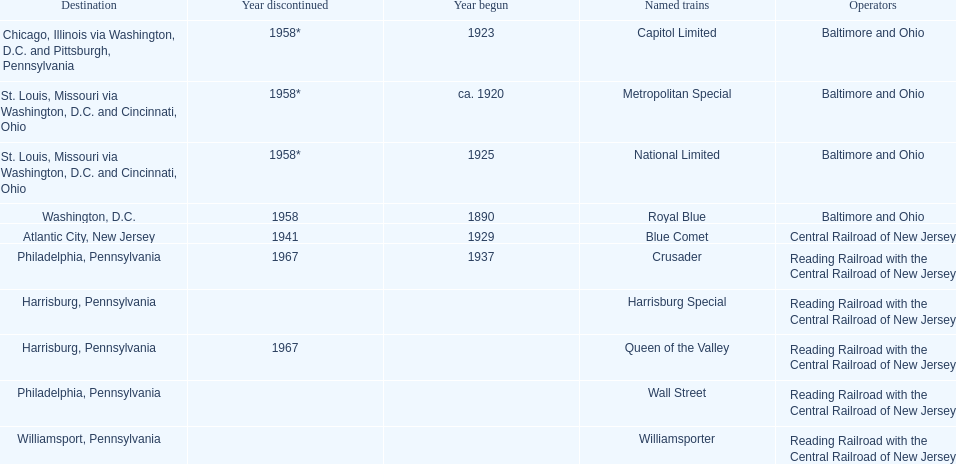Which train ran for the longest time? Royal Blue. Could you parse the entire table? {'header': ['Destination', 'Year discontinued', 'Year begun', 'Named trains', 'Operators'], 'rows': [['Chicago, Illinois via Washington, D.C. and Pittsburgh, Pennsylvania', '1958*', '1923', 'Capitol Limited', 'Baltimore and Ohio'], ['St. Louis, Missouri via Washington, D.C. and Cincinnati, Ohio', '1958*', 'ca. 1920', 'Metropolitan Special', 'Baltimore and Ohio'], ['St. Louis, Missouri via Washington, D.C. and Cincinnati, Ohio', '1958*', '1925', 'National Limited', 'Baltimore and Ohio'], ['Washington, D.C.', '1958', '1890', 'Royal Blue', 'Baltimore and Ohio'], ['Atlantic City, New Jersey', '1941', '1929', 'Blue Comet', 'Central Railroad of New Jersey'], ['Philadelphia, Pennsylvania', '1967', '1937', 'Crusader', 'Reading Railroad with the Central Railroad of New Jersey'], ['Harrisburg, Pennsylvania', '', '', 'Harrisburg Special', 'Reading Railroad with the Central Railroad of New Jersey'], ['Harrisburg, Pennsylvania', '1967', '', 'Queen of the Valley', 'Reading Railroad with the Central Railroad of New Jersey'], ['Philadelphia, Pennsylvania', '', '', 'Wall Street', 'Reading Railroad with the Central Railroad of New Jersey'], ['Williamsport, Pennsylvania', '', '', 'Williamsporter', 'Reading Railroad with the Central Railroad of New Jersey']]} 